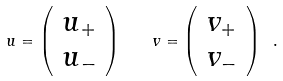Convert formula to latex. <formula><loc_0><loc_0><loc_500><loc_500>u = \left ( \begin{array} { c } u _ { + } \\ u _ { - } \end{array} \right ) \quad v = \left ( \begin{array} { c } v _ { + } \\ v _ { - } \end{array} \right ) \ .</formula> 